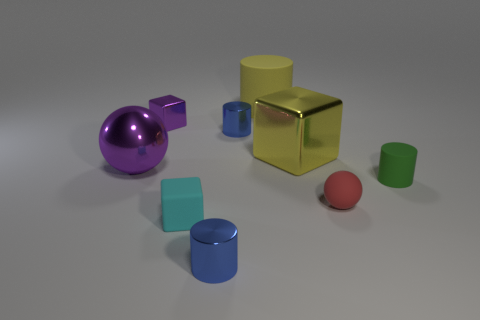Subtract all small rubber cylinders. How many cylinders are left? 3 Subtract all purple spheres. How many spheres are left? 1 Subtract all blue cylinders. How many cyan cubes are left? 1 Subtract all metallic cubes. Subtract all small cyan rubber things. How many objects are left? 6 Add 1 cyan matte things. How many cyan matte things are left? 2 Add 7 cyan cubes. How many cyan cubes exist? 8 Subtract 1 purple blocks. How many objects are left? 8 Subtract all cylinders. How many objects are left? 5 Subtract 3 cylinders. How many cylinders are left? 1 Subtract all yellow cubes. Subtract all green cylinders. How many cubes are left? 2 